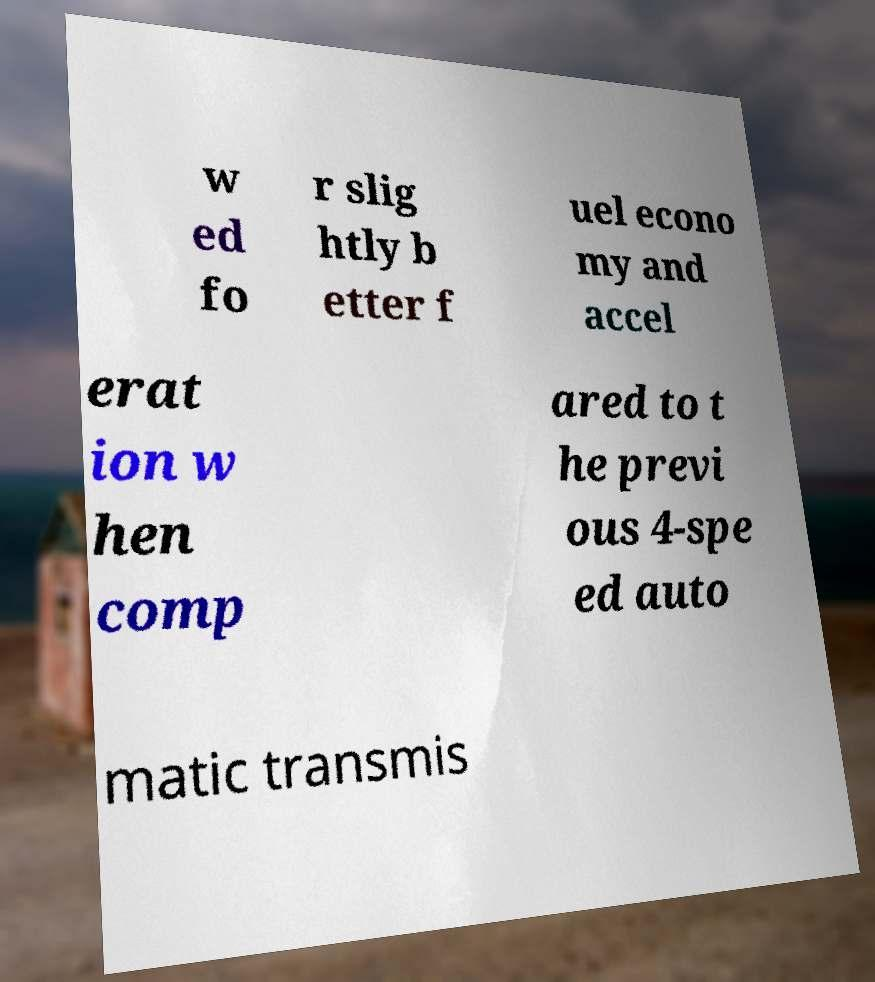Please read and relay the text visible in this image. What does it say? w ed fo r slig htly b etter f uel econo my and accel erat ion w hen comp ared to t he previ ous 4-spe ed auto matic transmis 